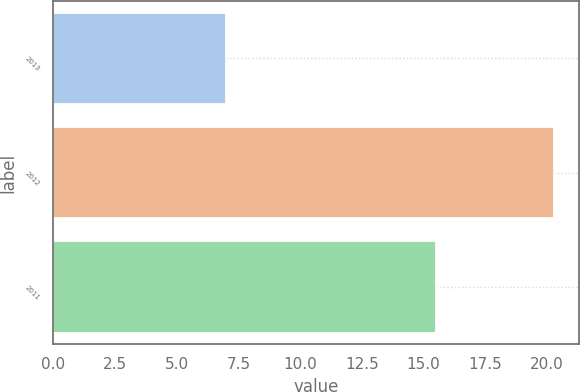Convert chart. <chart><loc_0><loc_0><loc_500><loc_500><bar_chart><fcel>2013<fcel>2012<fcel>2011<nl><fcel>7<fcel>20.3<fcel>15.5<nl></chart> 